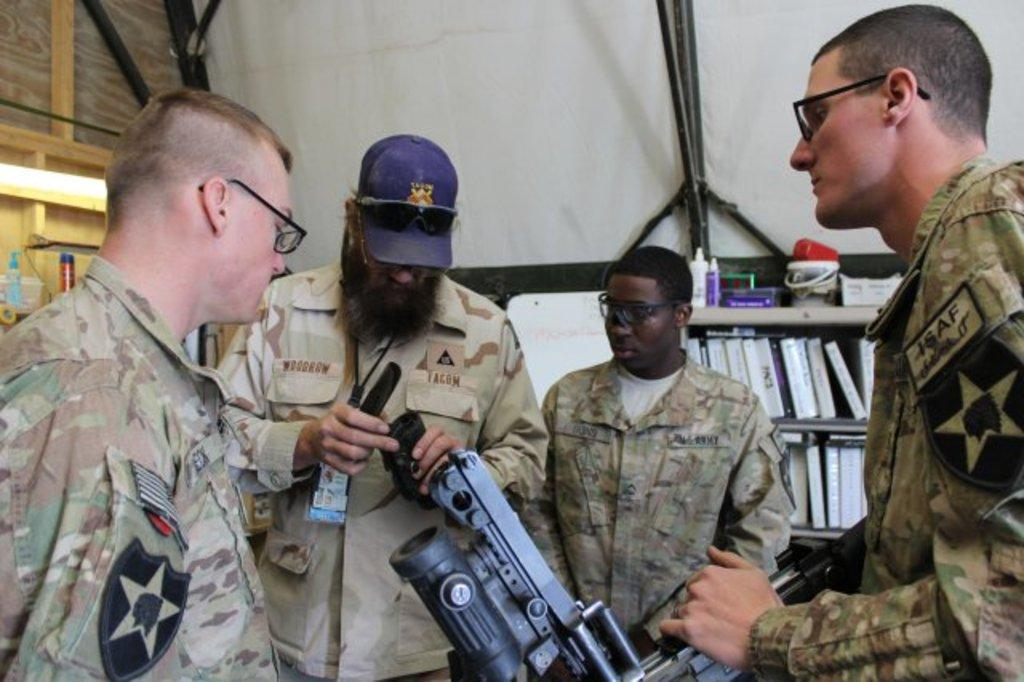How many soldiers are in the image? There are four soldiers in the image. What are the soldiers doing in the image? The soldiers are standing, and they are all watching a metal object. Which soldier is holding the metal object? The second soldier is holding the metal object. What can be seen in the background of the image? There is a bookshelf visible in the background of the image. What channel is the soldier with the metal object watching in the image? There is no television or channel visible in the image, so it cannot be determined. 